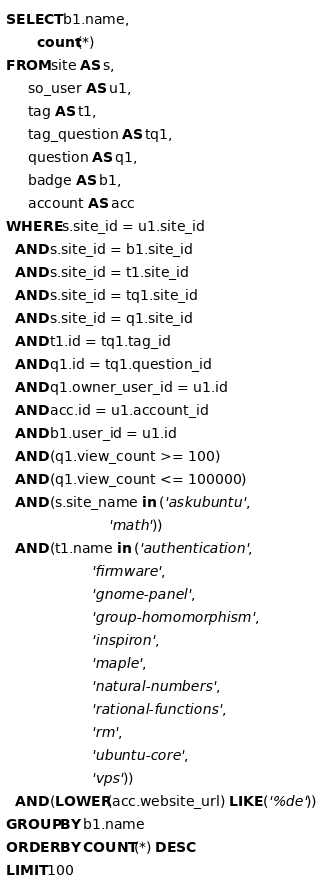<code> <loc_0><loc_0><loc_500><loc_500><_SQL_>SELECT b1.name,
       count(*)
FROM site AS s,
     so_user AS u1,
     tag AS t1,
     tag_question AS tq1,
     question AS q1,
     badge AS b1,
     account AS acc
WHERE s.site_id = u1.site_id
  AND s.site_id = b1.site_id
  AND s.site_id = t1.site_id
  AND s.site_id = tq1.site_id
  AND s.site_id = q1.site_id
  AND t1.id = tq1.tag_id
  AND q1.id = tq1.question_id
  AND q1.owner_user_id = u1.id
  AND acc.id = u1.account_id
  AND b1.user_id = u1.id
  AND (q1.view_count >= 100)
  AND (q1.view_count <= 100000)
  AND (s.site_name in ('askubuntu',
                       'math'))
  AND (t1.name in ('authentication',
                   'firmware',
                   'gnome-panel',
                   'group-homomorphism',
                   'inspiron',
                   'maple',
                   'natural-numbers',
                   'rational-functions',
                   'rm',
                   'ubuntu-core',
                   'vps'))
  AND (LOWER(acc.website_url) LIKE ('%de'))
GROUP BY b1.name
ORDER BY COUNT(*) DESC
LIMIT 100</code> 